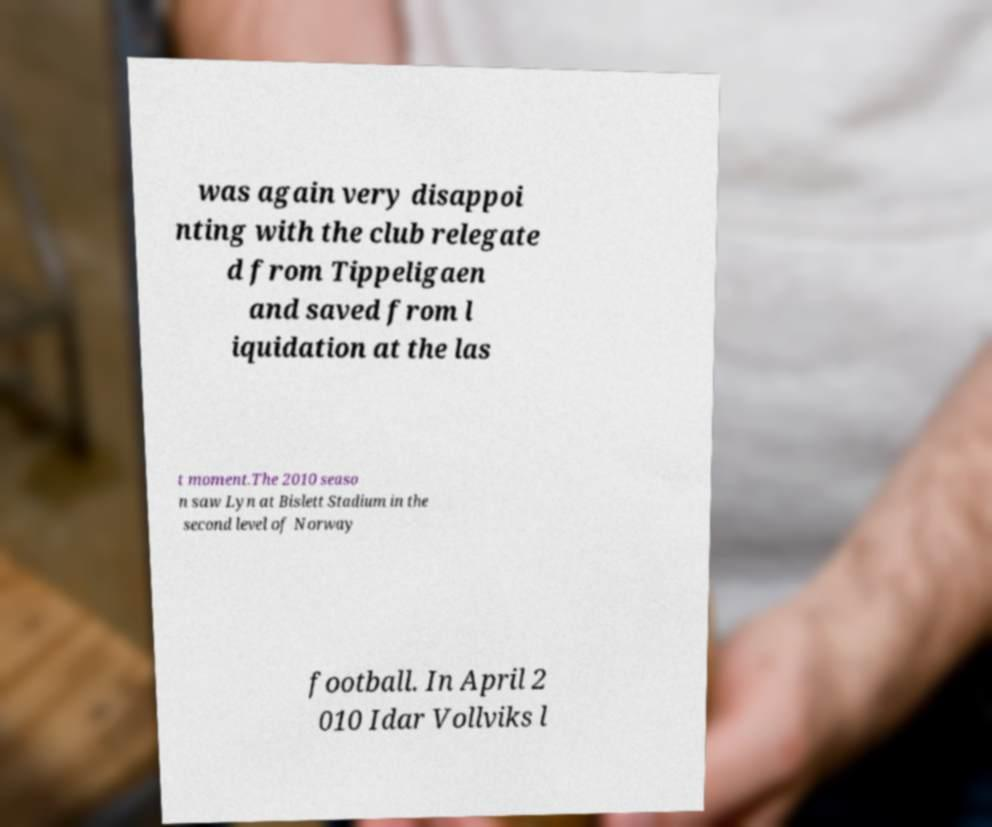Please read and relay the text visible in this image. What does it say? was again very disappoi nting with the club relegate d from Tippeligaen and saved from l iquidation at the las t moment.The 2010 seaso n saw Lyn at Bislett Stadium in the second level of Norway football. In April 2 010 Idar Vollviks l 